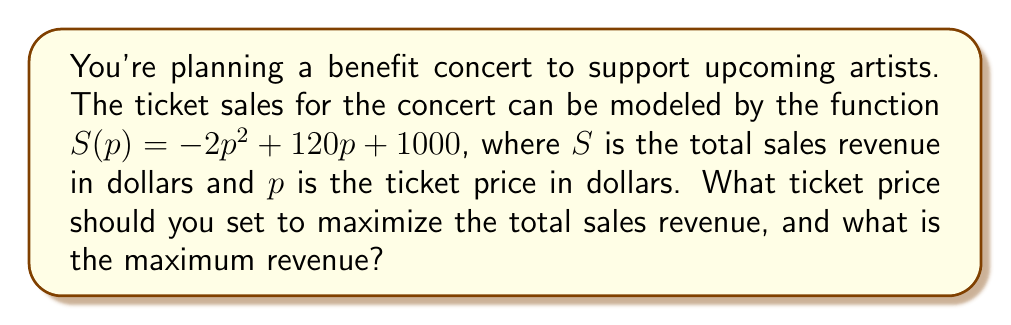Can you answer this question? To find the maximum point on this curve, we need to follow these steps:

1) The function $S(p) = -2p^2 + 120p + 1000$ is a quadratic function, which forms a parabola. The maximum point occurs at the vertex of this parabola.

2) For a quadratic function in the form $f(x) = ax^2 + bx + c$, the x-coordinate of the vertex is given by $x = -\frac{b}{2a}$.

3) In our case, $a = -2$, $b = 120$, and $c = 1000$. Let's substitute these values:

   $p = -\frac{120}{2(-2)} = -\frac{120}{-4} = 30$

4) This means the maximum revenue occurs when the ticket price is $30.

5) To find the maximum revenue, we need to substitute this price back into our original function:

   $S(30) = -2(30)^2 + 120(30) + 1000$
          $= -2(900) + 3600 + 1000$
          $= -1800 + 3600 + 1000$
          $= 2800$

Therefore, the maximum revenue is $2800.
Answer: Optimal ticket price: $30; Maximum revenue: $2800 